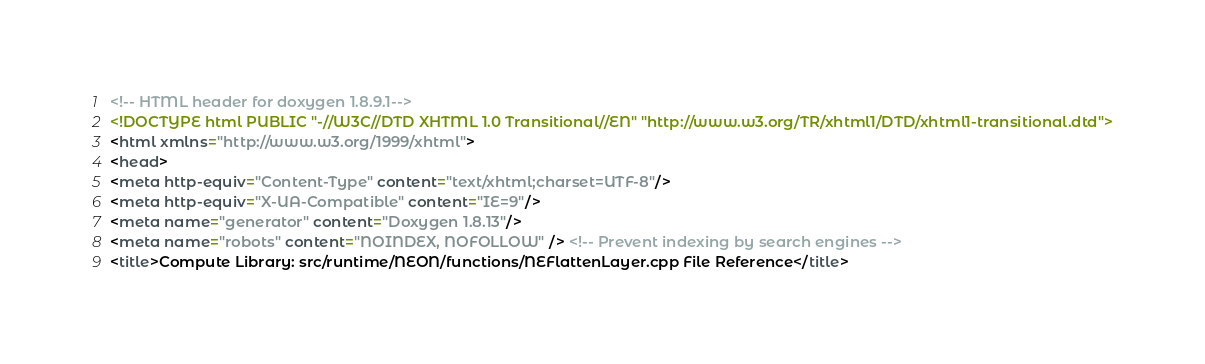<code> <loc_0><loc_0><loc_500><loc_500><_HTML_><!-- HTML header for doxygen 1.8.9.1-->
<!DOCTYPE html PUBLIC "-//W3C//DTD XHTML 1.0 Transitional//EN" "http://www.w3.org/TR/xhtml1/DTD/xhtml1-transitional.dtd">
<html xmlns="http://www.w3.org/1999/xhtml">
<head>
<meta http-equiv="Content-Type" content="text/xhtml;charset=UTF-8"/>
<meta http-equiv="X-UA-Compatible" content="IE=9"/>
<meta name="generator" content="Doxygen 1.8.13"/>
<meta name="robots" content="NOINDEX, NOFOLLOW" /> <!-- Prevent indexing by search engines -->
<title>Compute Library: src/runtime/NEON/functions/NEFlattenLayer.cpp File Reference</title></code> 